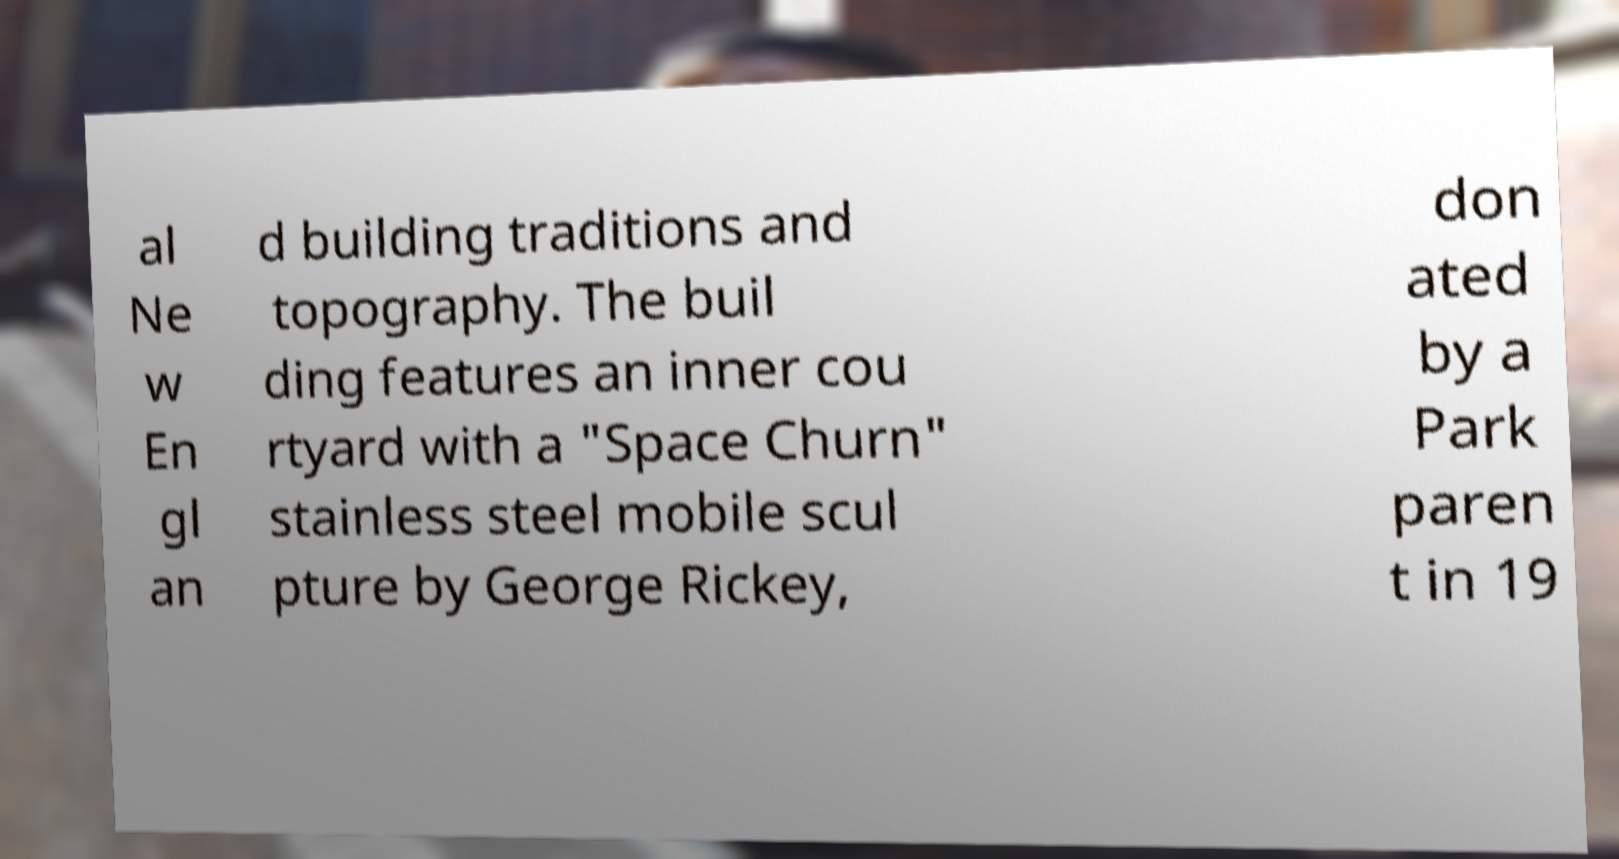Please read and relay the text visible in this image. What does it say? al Ne w En gl an d building traditions and topography. The buil ding features an inner cou rtyard with a "Space Churn" stainless steel mobile scul pture by George Rickey, don ated by a Park paren t in 19 